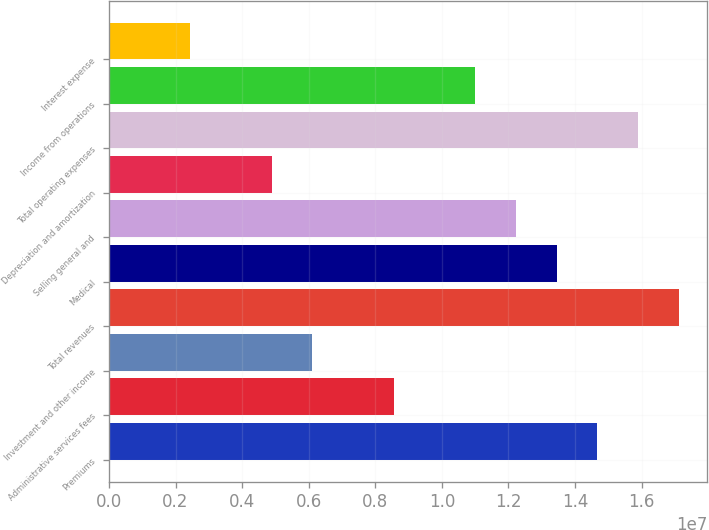<chart> <loc_0><loc_0><loc_500><loc_500><bar_chart><fcel>Premiums<fcel>Administrative services fees<fcel>Investment and other income<fcel>Total revenues<fcel>Medical<fcel>Selling general and<fcel>Depreciation and amortization<fcel>Total operating expenses<fcel>Income from operations<fcel>Interest expense<nl><fcel>1.46716e+07<fcel>8.55842e+06<fcel>6.11316e+06<fcel>1.71168e+07<fcel>1.34489e+07<fcel>1.22263e+07<fcel>4.89053e+06<fcel>1.58942e+07<fcel>1.10037e+07<fcel>2.44526e+06<nl></chart> 